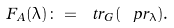Convert formula to latex. <formula><loc_0><loc_0><loc_500><loc_500>F _ { A } ( \lambda ) \colon = \ t r _ { G } ( \ p r _ { \lambda } ) .</formula> 